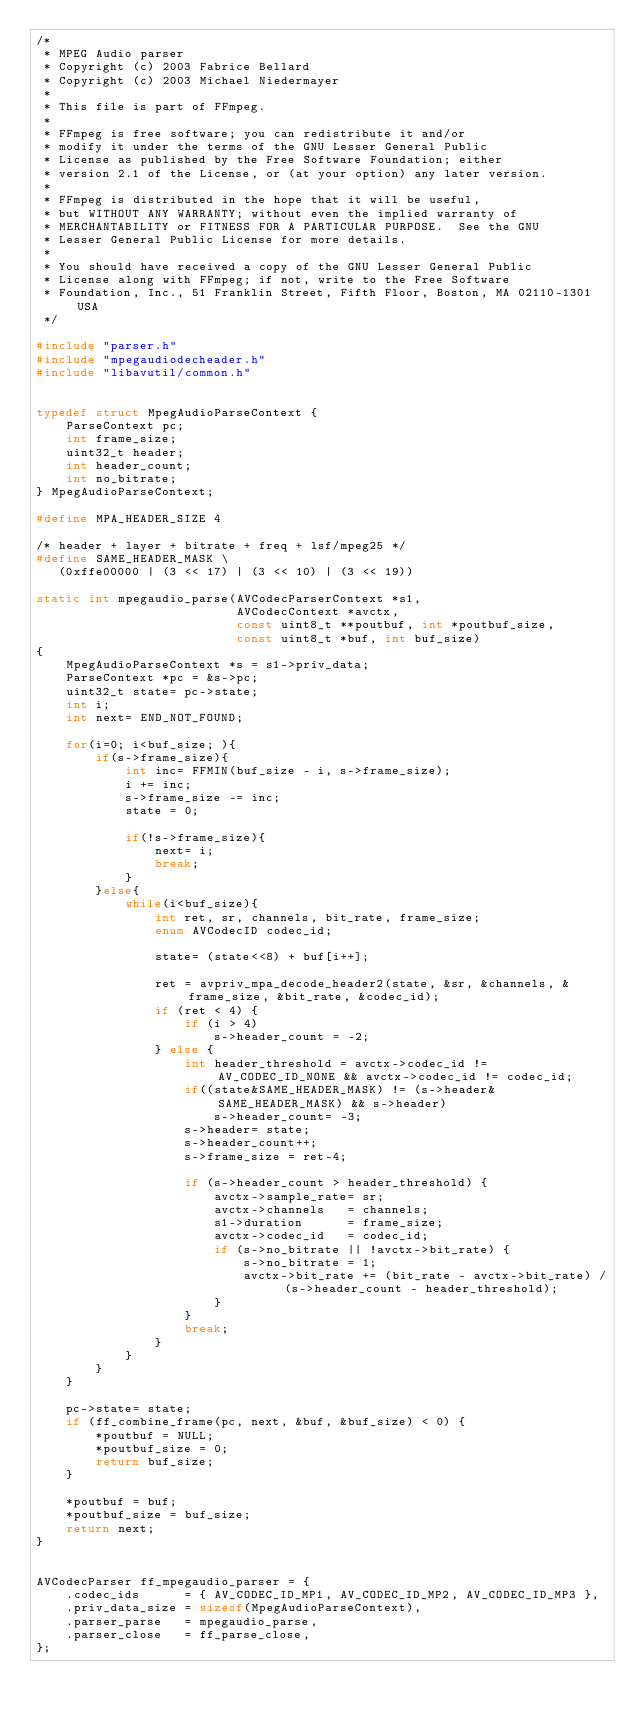<code> <loc_0><loc_0><loc_500><loc_500><_C_>/*
 * MPEG Audio parser
 * Copyright (c) 2003 Fabrice Bellard
 * Copyright (c) 2003 Michael Niedermayer
 *
 * This file is part of FFmpeg.
 *
 * FFmpeg is free software; you can redistribute it and/or
 * modify it under the terms of the GNU Lesser General Public
 * License as published by the Free Software Foundation; either
 * version 2.1 of the License, or (at your option) any later version.
 *
 * FFmpeg is distributed in the hope that it will be useful,
 * but WITHOUT ANY WARRANTY; without even the implied warranty of
 * MERCHANTABILITY or FITNESS FOR A PARTICULAR PURPOSE.  See the GNU
 * Lesser General Public License for more details.
 *
 * You should have received a copy of the GNU Lesser General Public
 * License along with FFmpeg; if not, write to the Free Software
 * Foundation, Inc., 51 Franklin Street, Fifth Floor, Boston, MA 02110-1301 USA
 */

#include "parser.h"
#include "mpegaudiodecheader.h"
#include "libavutil/common.h"


typedef struct MpegAudioParseContext {
    ParseContext pc;
    int frame_size;
    uint32_t header;
    int header_count;
    int no_bitrate;
} MpegAudioParseContext;

#define MPA_HEADER_SIZE 4

/* header + layer + bitrate + freq + lsf/mpeg25 */
#define SAME_HEADER_MASK \
   (0xffe00000 | (3 << 17) | (3 << 10) | (3 << 19))

static int mpegaudio_parse(AVCodecParserContext *s1,
                           AVCodecContext *avctx,
                           const uint8_t **poutbuf, int *poutbuf_size,
                           const uint8_t *buf, int buf_size)
{
    MpegAudioParseContext *s = s1->priv_data;
    ParseContext *pc = &s->pc;
    uint32_t state= pc->state;
    int i;
    int next= END_NOT_FOUND;

    for(i=0; i<buf_size; ){
        if(s->frame_size){
            int inc= FFMIN(buf_size - i, s->frame_size);
            i += inc;
            s->frame_size -= inc;
            state = 0;

            if(!s->frame_size){
                next= i;
                break;
            }
        }else{
            while(i<buf_size){
                int ret, sr, channels, bit_rate, frame_size;
                enum AVCodecID codec_id;

                state= (state<<8) + buf[i++];

                ret = avpriv_mpa_decode_header2(state, &sr, &channels, &frame_size, &bit_rate, &codec_id);
                if (ret < 4) {
                    if (i > 4)
                        s->header_count = -2;
                } else {
                    int header_threshold = avctx->codec_id != AV_CODEC_ID_NONE && avctx->codec_id != codec_id;
                    if((state&SAME_HEADER_MASK) != (s->header&SAME_HEADER_MASK) && s->header)
                        s->header_count= -3;
                    s->header= state;
                    s->header_count++;
                    s->frame_size = ret-4;

                    if (s->header_count > header_threshold) {
                        avctx->sample_rate= sr;
                        avctx->channels   = channels;
                        s1->duration      = frame_size;
                        avctx->codec_id   = codec_id;
                        if (s->no_bitrate || !avctx->bit_rate) {
                            s->no_bitrate = 1;
                            avctx->bit_rate += (bit_rate - avctx->bit_rate) / (s->header_count - header_threshold);
                        }
                    }
                    break;
                }
            }
        }
    }

    pc->state= state;
    if (ff_combine_frame(pc, next, &buf, &buf_size) < 0) {
        *poutbuf = NULL;
        *poutbuf_size = 0;
        return buf_size;
    }

    *poutbuf = buf;
    *poutbuf_size = buf_size;
    return next;
}


AVCodecParser ff_mpegaudio_parser = {
    .codec_ids      = { AV_CODEC_ID_MP1, AV_CODEC_ID_MP2, AV_CODEC_ID_MP3 },
    .priv_data_size = sizeof(MpegAudioParseContext),
    .parser_parse   = mpegaudio_parse,
    .parser_close   = ff_parse_close,
};
</code> 